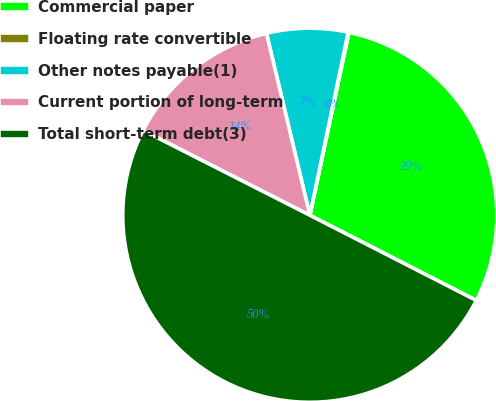Convert chart to OTSL. <chart><loc_0><loc_0><loc_500><loc_500><pie_chart><fcel>Commercial paper<fcel>Floating rate convertible<fcel>Other notes payable(1)<fcel>Current portion of long-term<fcel>Total short-term debt(3)<nl><fcel>29.17%<fcel>0.07%<fcel>7.01%<fcel>13.79%<fcel>49.96%<nl></chart> 